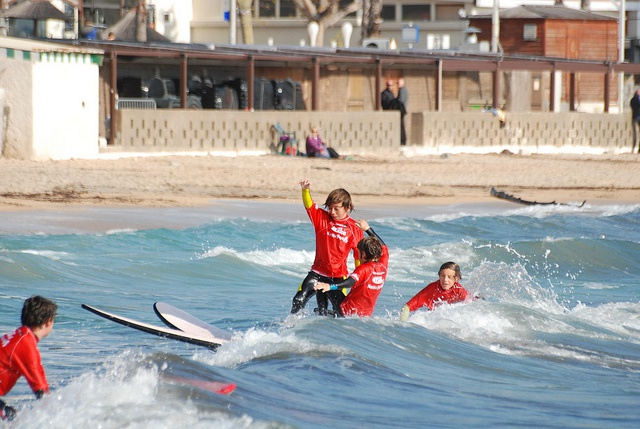Describe the objects in this image and their specific colors. I can see people in gray, red, brown, black, and darkgray tones, people in gray, red, black, brown, and salmon tones, people in gray, red, salmon, brown, and black tones, people in gray, brown, red, and lightpink tones, and surfboard in gray, white, darkgray, and black tones in this image. 